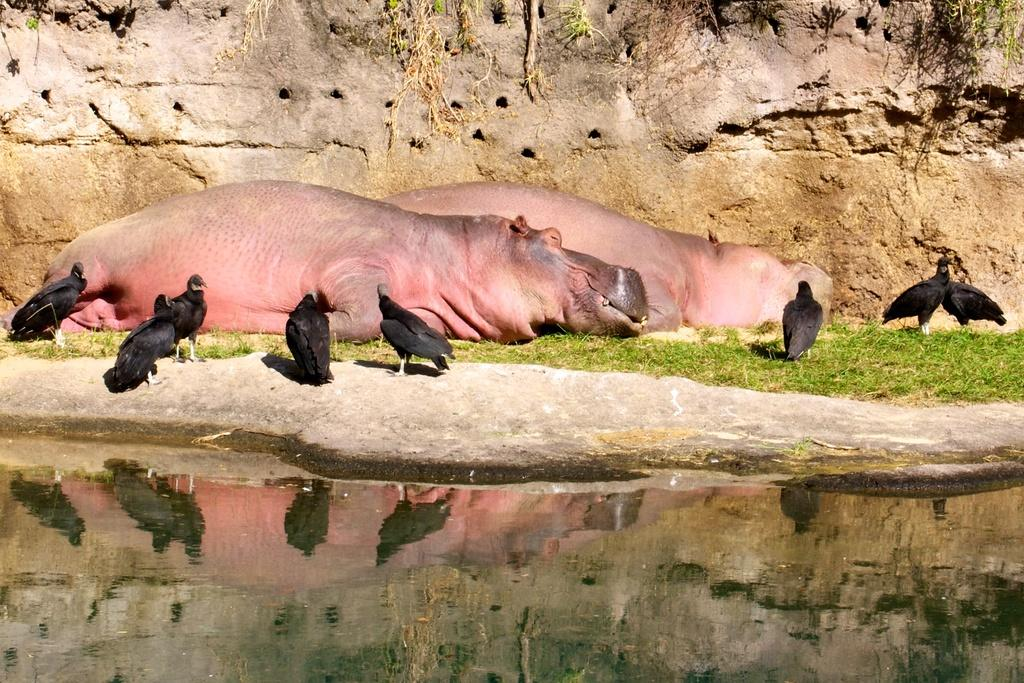What type of living organisms can be seen in the image? There are animals and birds visible in the image. What natural element is present in the image? There is water visible in the image. What type of vegetation is present in the image? There is grass in the image. What can be seen in the background of the image? There is a wall in the background of the image. What type of cable can be seen connecting the birds in the image? There is no cable connecting the birds in the image; they are not attached or linked in any way. 